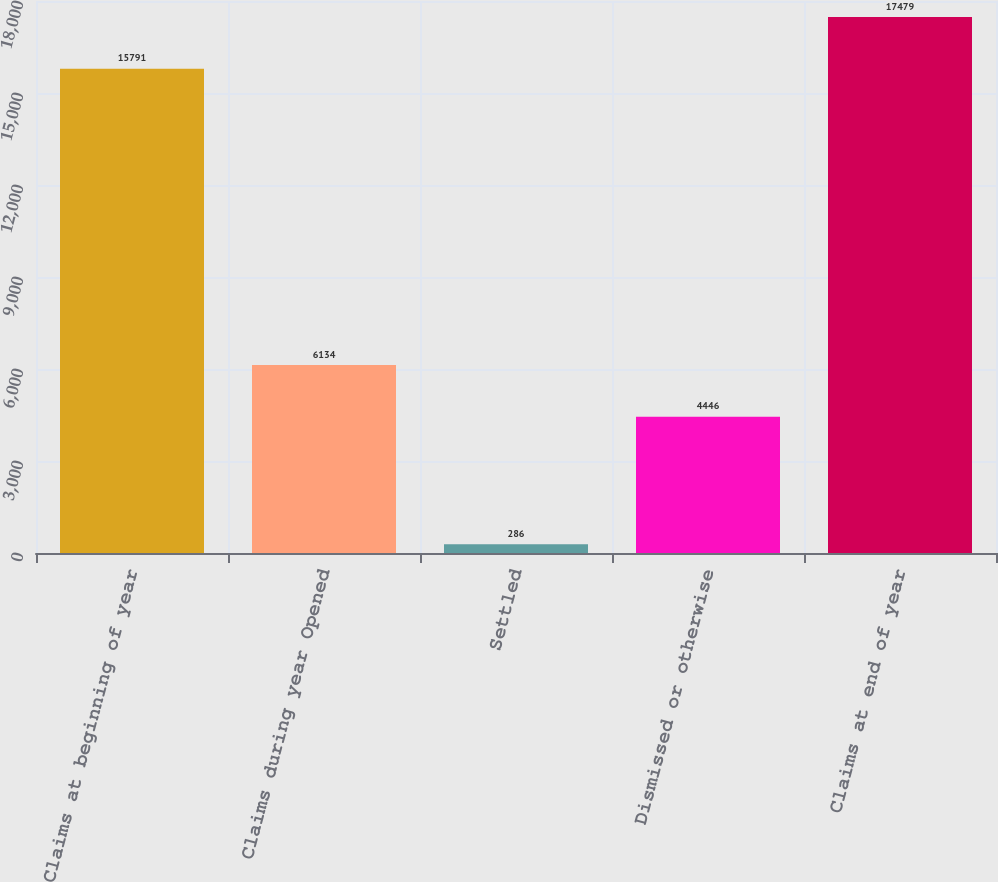Convert chart to OTSL. <chart><loc_0><loc_0><loc_500><loc_500><bar_chart><fcel>Claims at beginning of year<fcel>Claims during year Opened<fcel>Settled<fcel>Dismissed or otherwise<fcel>Claims at end of year<nl><fcel>15791<fcel>6134<fcel>286<fcel>4446<fcel>17479<nl></chart> 